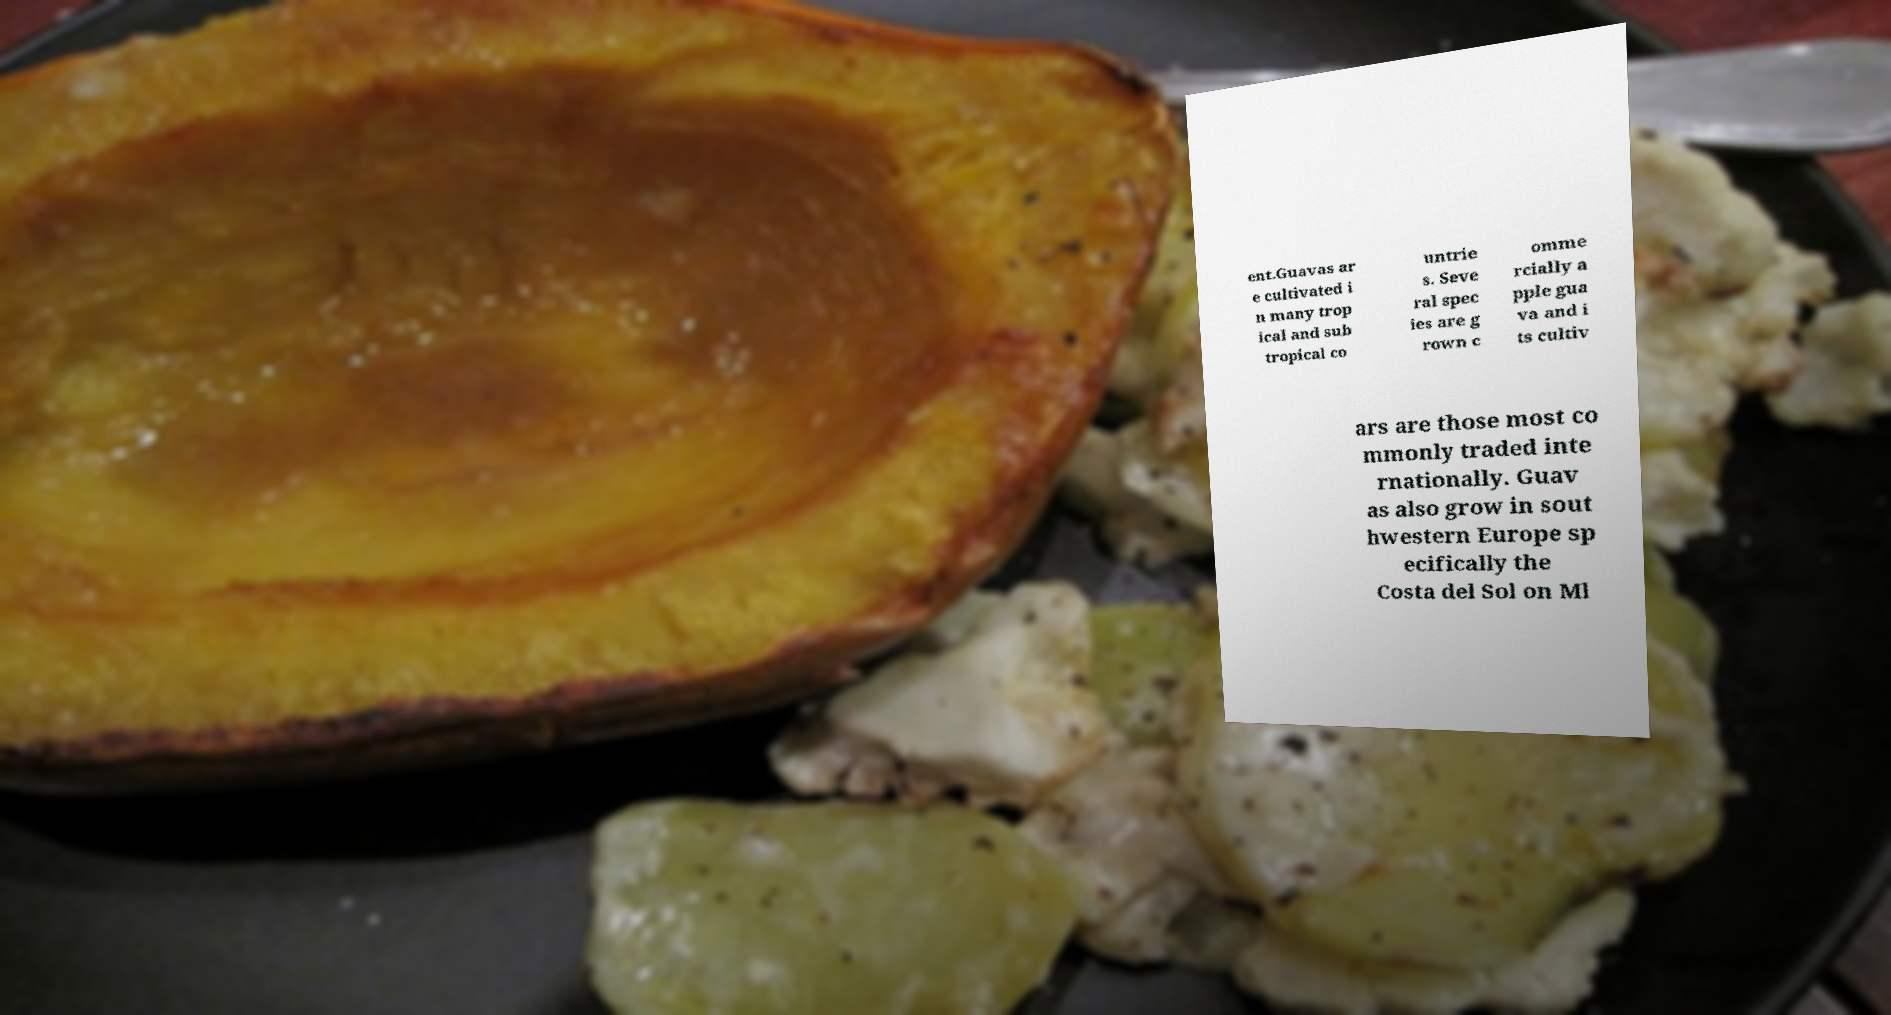How can guavas be incorporated into meals? Guavas are incredibly versatile in culinary use. They can be eaten raw, juiced, or added to fruit salads for a tropical twist. In cooking, guavas can be transformed into jellies, preserves, and sauces. As seen in the image, they can also be baked into desserts like tarts or blended into smoothies and cocktails for a refreshing flavor. 